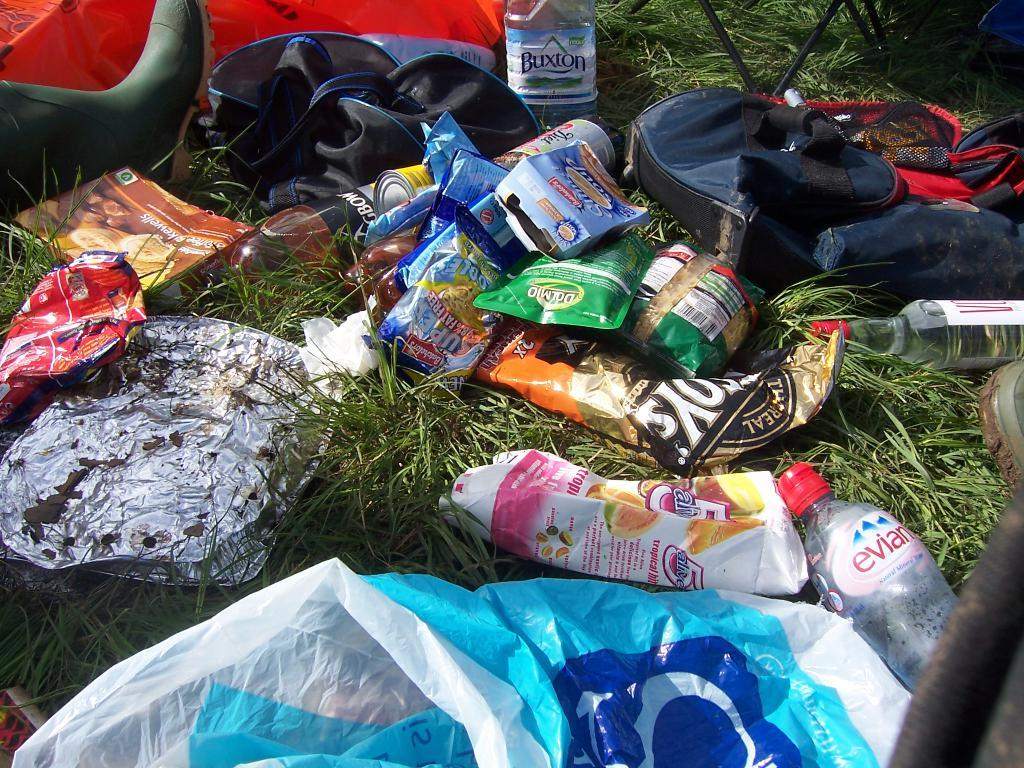What type of objects are on the grass floor in the image? There are bottles, wrappers, aluminium foil, a book, a bag, boots, covers, and a stand on the grass floor. What might be used to hold or contain items in the image? The bag and the stand on the grass floor might be used to hold or contain items. What type of footwear is visible on the grass floor? Boots are visible on the grass floor. What might be used for reading or learning in the image? The book on the grass floor might be used for reading or learning. What type of crack can be seen on the loaf of bread in the image? There is no loaf of bread present in the image, so no crack can be observed. 